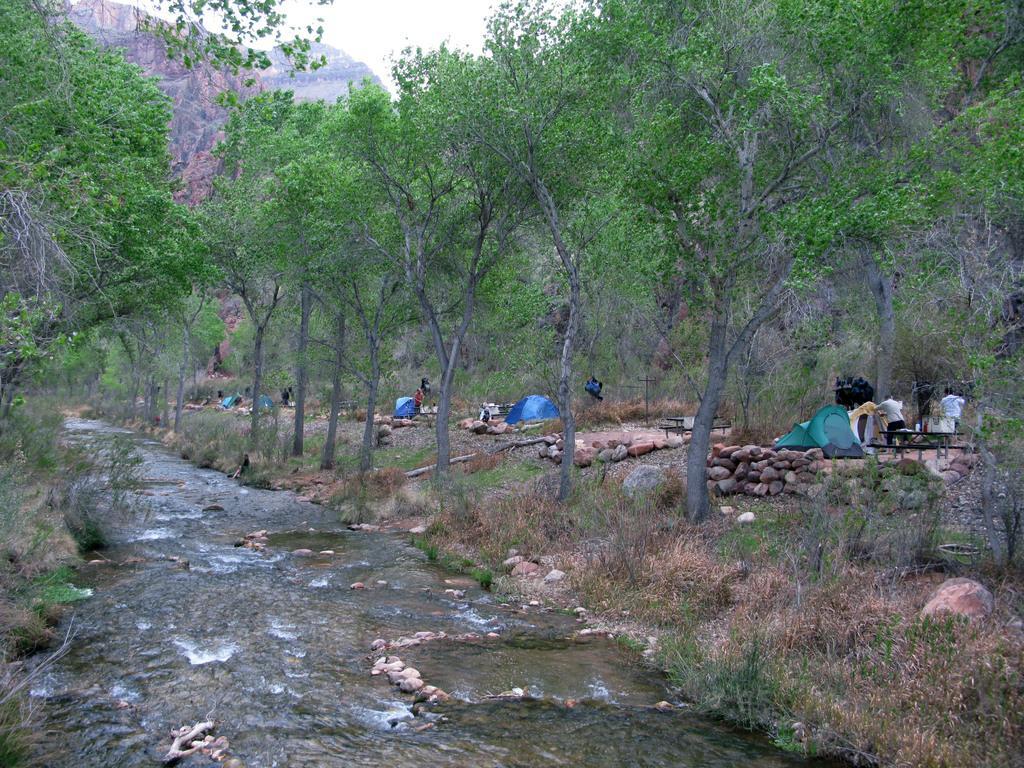Could you give a brief overview of what you see in this image? In this image, I can see a river, trees and plants. On the right side of the image, I can see few people, tents and rocks. In the background, there is a hill and the sky. 